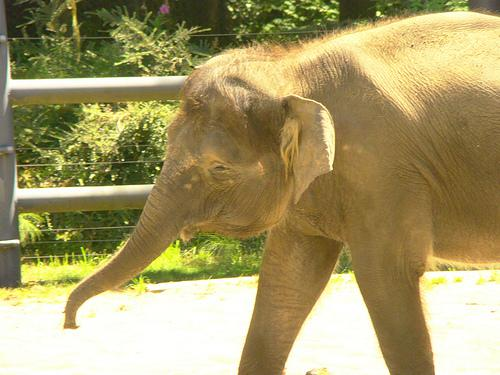Question: what color is the elephant?
Choices:
A. Black.
B. Gray.
C. Brown.
D. White.
Answer with the letter. Answer: B Question: who is the main focus of this photo?
Choices:
A. Her teeth.
B. Her eyes.
C. Her hair.
D. An elephant.
Answer with the letter. Answer: D Question: where was this photo taken?
Choices:
A. At an animal exhibit.
B. At school.
C. At the fire.
D. At the back fence.
Answer with the letter. Answer: A Question: what is on the elephant's face?
Choices:
A. Tusks.
B. A trunk.
C. Hair.
D. Rain.
Answer with the letter. Answer: B Question: how many elephants are visible?
Choices:
A. 1.
B. 2.
C. 3.
D. 4.
Answer with the letter. Answer: A 